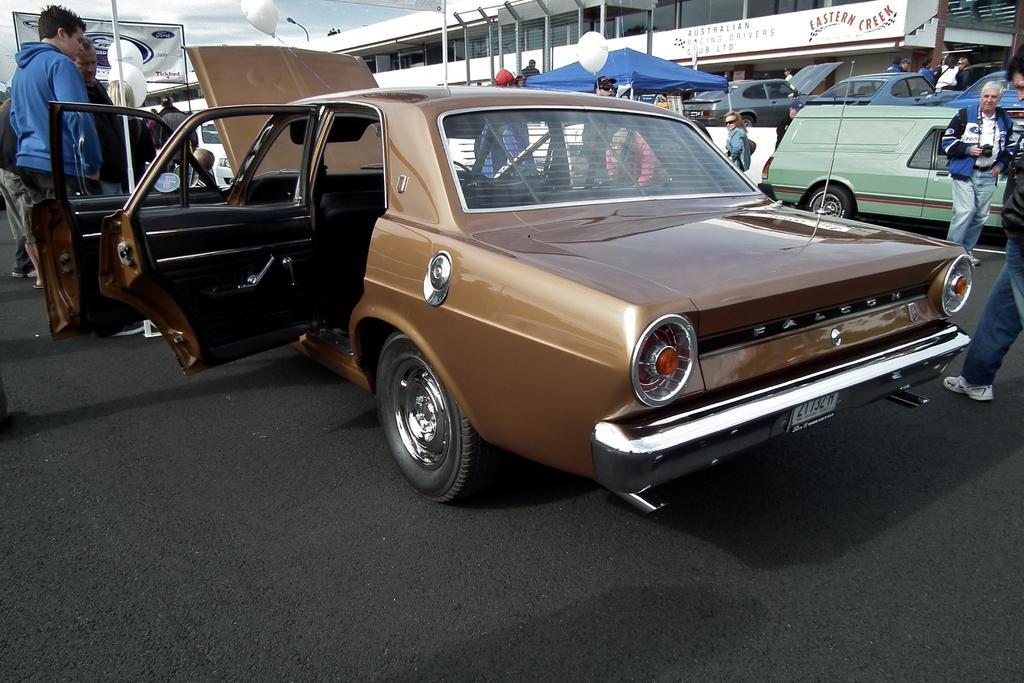How would you summarize this image in a sentence or two? There are people and we can see vehicles on the road. In the background we can see building,balloons,tent,light,banner and sky. 